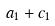<formula> <loc_0><loc_0><loc_500><loc_500>a _ { 1 } + c _ { 1 }</formula> 